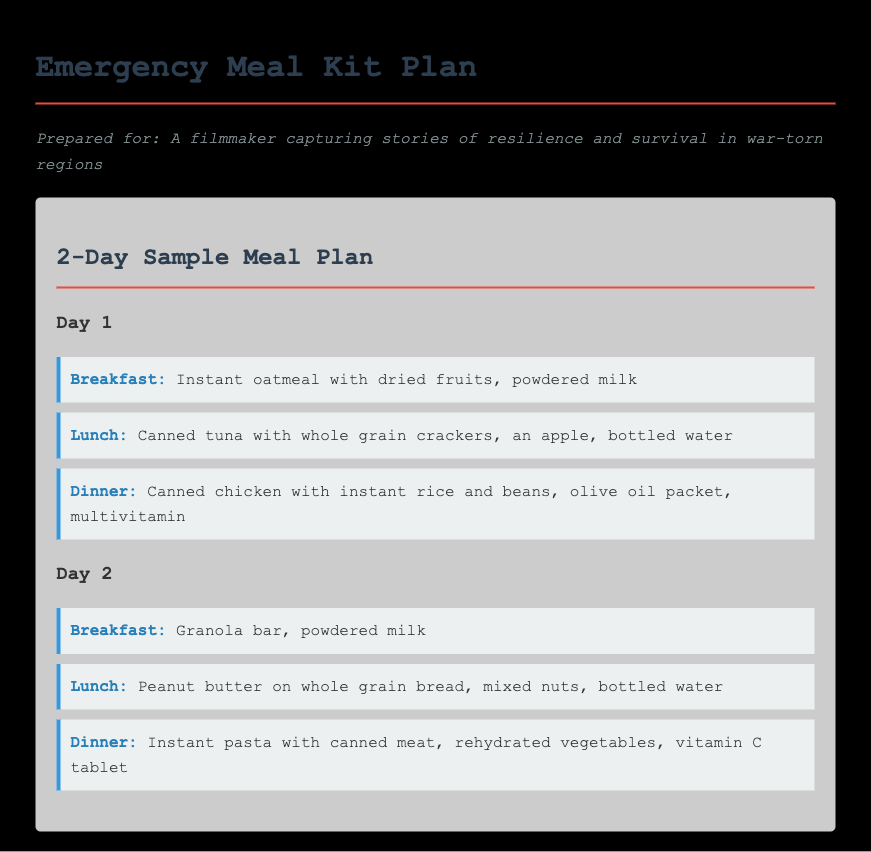what is the title of the document? The title of the document is provided in the header section of the HTML code.
Answer: Emergency Meal Kit Plan how many days does the meal plan cover? The document outlines a meal plan consisting of multiple meals for a specified number of days.
Answer: 2 what is listed as the breakfast for Day 1? The meal plan specifies the meals for each day, including breakfast for Day 1.
Answer: Instant oatmeal with dried fruits, powdered milk which fruit is included in the lunch for Day 1? The lunch meal for Day 1 includes a specific fruit mentioned in the meal plan.
Answer: an apple what type of meal is included for Day 2 dinner? The meal plan specifies dinner options for Day 2, showing the type of meal provided.
Answer: Instant pasta with canned meat, rehydrated vegetables, vitamin C tablet what is the primary protein source in the lunch for Day 1? The lunch contains a specific type of protein, which can be identified from the meal plan.
Answer: Canned tuna how many meals are served for each day? The meal plan outlines the diet structure for each day in terms of meal quantities.
Answer: 3 what is the packaging type suggested for the meals? The document indicates the need for conditions suitable for storing emergency meals, including compact packaging.
Answer: compact packaging what supplement is mentioned for Day 1 dinner? The document specifies nutritional supplements or vitamins included in each day's meals.
Answer: multivitamin 